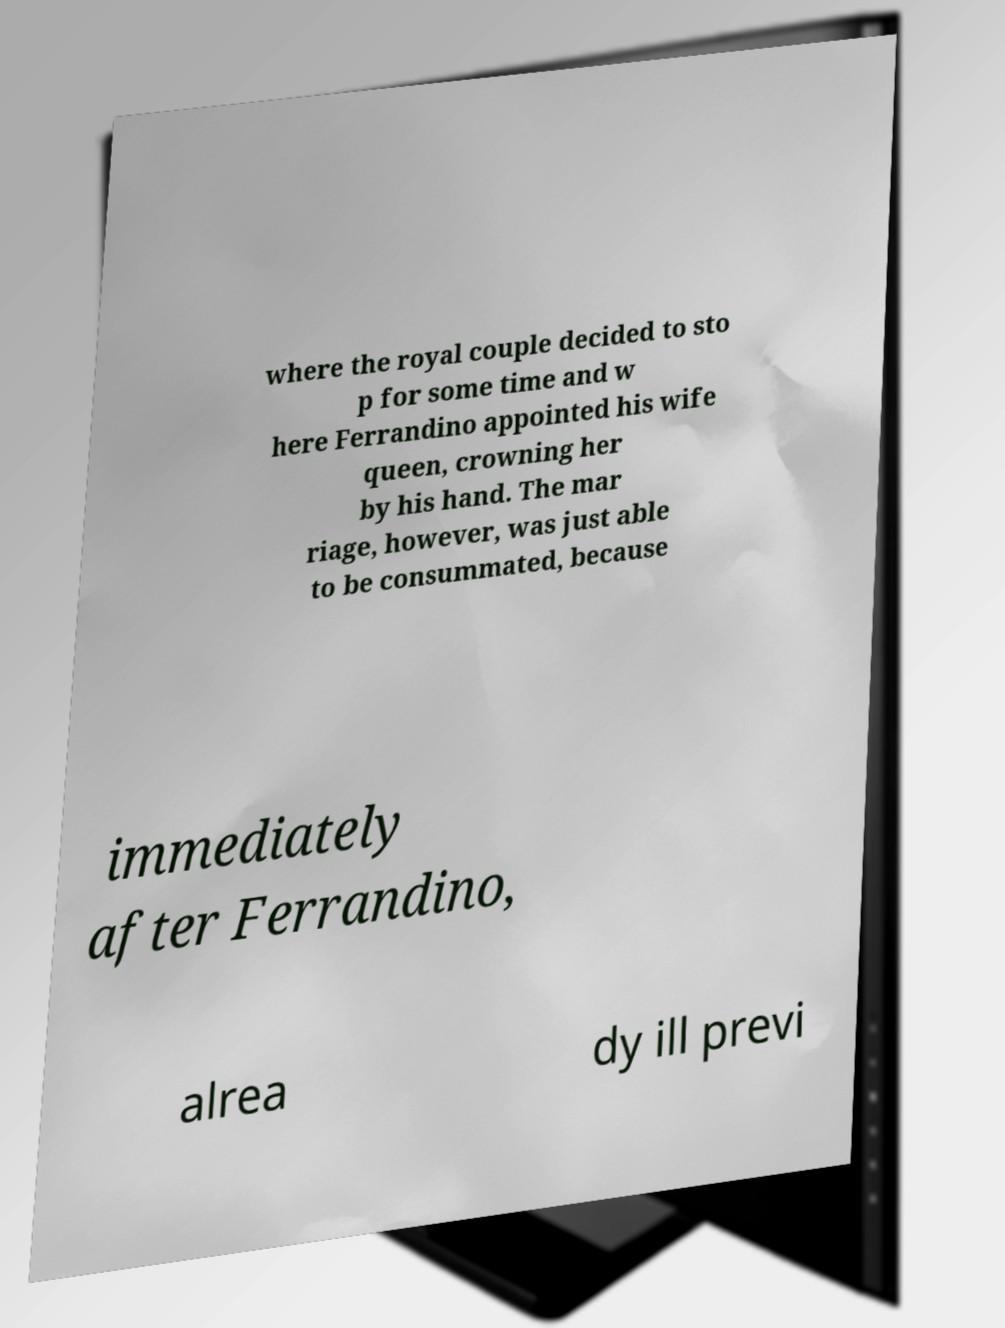Could you extract and type out the text from this image? where the royal couple decided to sto p for some time and w here Ferrandino appointed his wife queen, crowning her by his hand. The mar riage, however, was just able to be consummated, because immediately after Ferrandino, alrea dy ill previ 